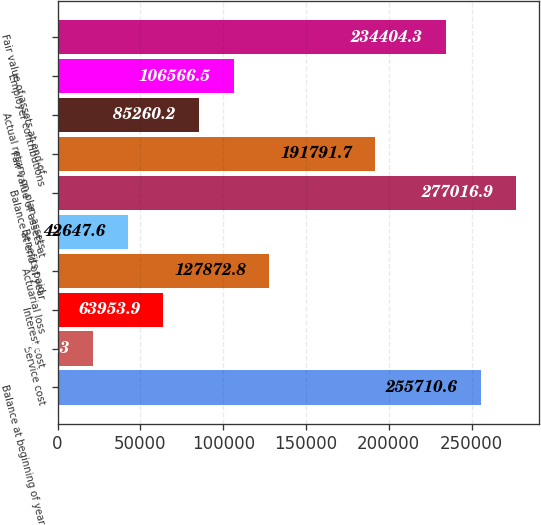<chart> <loc_0><loc_0><loc_500><loc_500><bar_chart><fcel>Balance at beginning of year<fcel>Service cost<fcel>Interest cost<fcel>Actuarial loss<fcel>Benefits paid<fcel>Balance at end of year<fcel>Fair value of assets at<fcel>Actual return on plan assets<fcel>Employer contributions<fcel>Fair value of assets at end of<nl><fcel>255711<fcel>21341.3<fcel>63953.9<fcel>127873<fcel>42647.6<fcel>277017<fcel>191792<fcel>85260.2<fcel>106566<fcel>234404<nl></chart> 